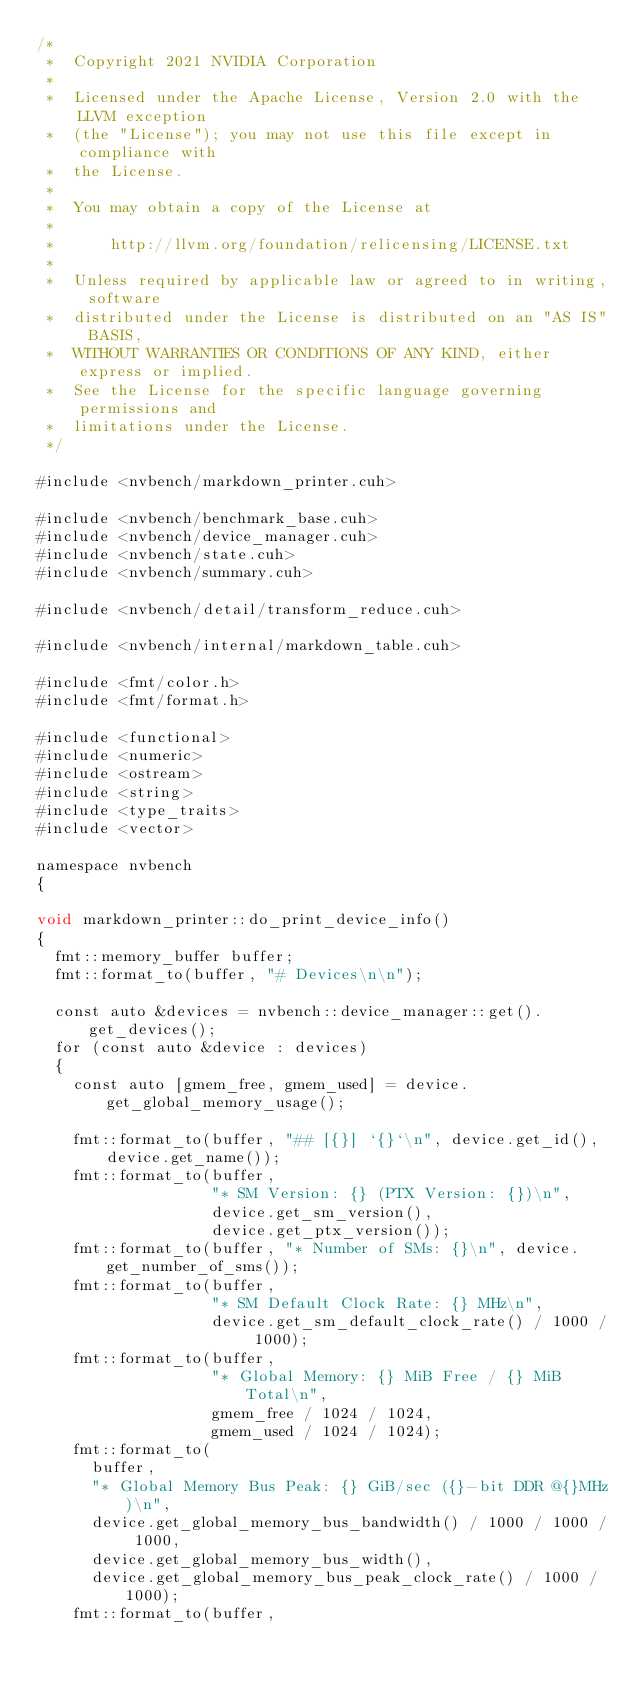Convert code to text. <code><loc_0><loc_0><loc_500><loc_500><_Cuda_>/*
 *  Copyright 2021 NVIDIA Corporation
 *
 *  Licensed under the Apache License, Version 2.0 with the LLVM exception
 *  (the "License"); you may not use this file except in compliance with
 *  the License.
 *
 *  You may obtain a copy of the License at
 *
 *      http://llvm.org/foundation/relicensing/LICENSE.txt
 *
 *  Unless required by applicable law or agreed to in writing, software
 *  distributed under the License is distributed on an "AS IS" BASIS,
 *  WITHOUT WARRANTIES OR CONDITIONS OF ANY KIND, either express or implied.
 *  See the License for the specific language governing permissions and
 *  limitations under the License.
 */

#include <nvbench/markdown_printer.cuh>

#include <nvbench/benchmark_base.cuh>
#include <nvbench/device_manager.cuh>
#include <nvbench/state.cuh>
#include <nvbench/summary.cuh>

#include <nvbench/detail/transform_reduce.cuh>

#include <nvbench/internal/markdown_table.cuh>

#include <fmt/color.h>
#include <fmt/format.h>

#include <functional>
#include <numeric>
#include <ostream>
#include <string>
#include <type_traits>
#include <vector>

namespace nvbench
{

void markdown_printer::do_print_device_info()
{
  fmt::memory_buffer buffer;
  fmt::format_to(buffer, "# Devices\n\n");

  const auto &devices = nvbench::device_manager::get().get_devices();
  for (const auto &device : devices)
  {
    const auto [gmem_free, gmem_used] = device.get_global_memory_usage();

    fmt::format_to(buffer, "## [{}] `{}`\n", device.get_id(), device.get_name());
    fmt::format_to(buffer,
                   "* SM Version: {} (PTX Version: {})\n",
                   device.get_sm_version(),
                   device.get_ptx_version());
    fmt::format_to(buffer, "* Number of SMs: {}\n", device.get_number_of_sms());
    fmt::format_to(buffer,
                   "* SM Default Clock Rate: {} MHz\n",
                   device.get_sm_default_clock_rate() / 1000 / 1000);
    fmt::format_to(buffer,
                   "* Global Memory: {} MiB Free / {} MiB Total\n",
                   gmem_free / 1024 / 1024,
                   gmem_used / 1024 / 1024);
    fmt::format_to(
      buffer,
      "* Global Memory Bus Peak: {} GiB/sec ({}-bit DDR @{}MHz)\n",
      device.get_global_memory_bus_bandwidth() / 1000 / 1000 / 1000,
      device.get_global_memory_bus_width(),
      device.get_global_memory_bus_peak_clock_rate() / 1000 / 1000);
    fmt::format_to(buffer,</code> 